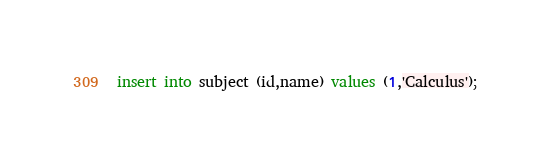<code> <loc_0><loc_0><loc_500><loc_500><_SQL_>insert into subject (id,name) values (1,'Calculus');</code> 